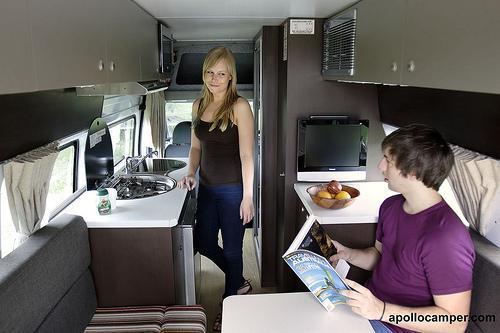How many people are in the picture?
Give a very brief answer. 2. How many apples are in the bowl?
Give a very brief answer. 1. 